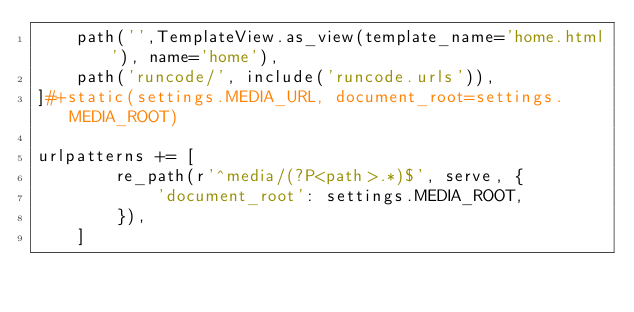Convert code to text. <code><loc_0><loc_0><loc_500><loc_500><_Python_>    path('',TemplateView.as_view(template_name='home.html'), name='home'),
    path('runcode/', include('runcode.urls')),
]#+static(settings.MEDIA_URL, document_root=settings.MEDIA_ROOT)

urlpatterns += [
        re_path(r'^media/(?P<path>.*)$', serve, {
            'document_root': settings.MEDIA_ROOT,
        }),
    ]
</code> 